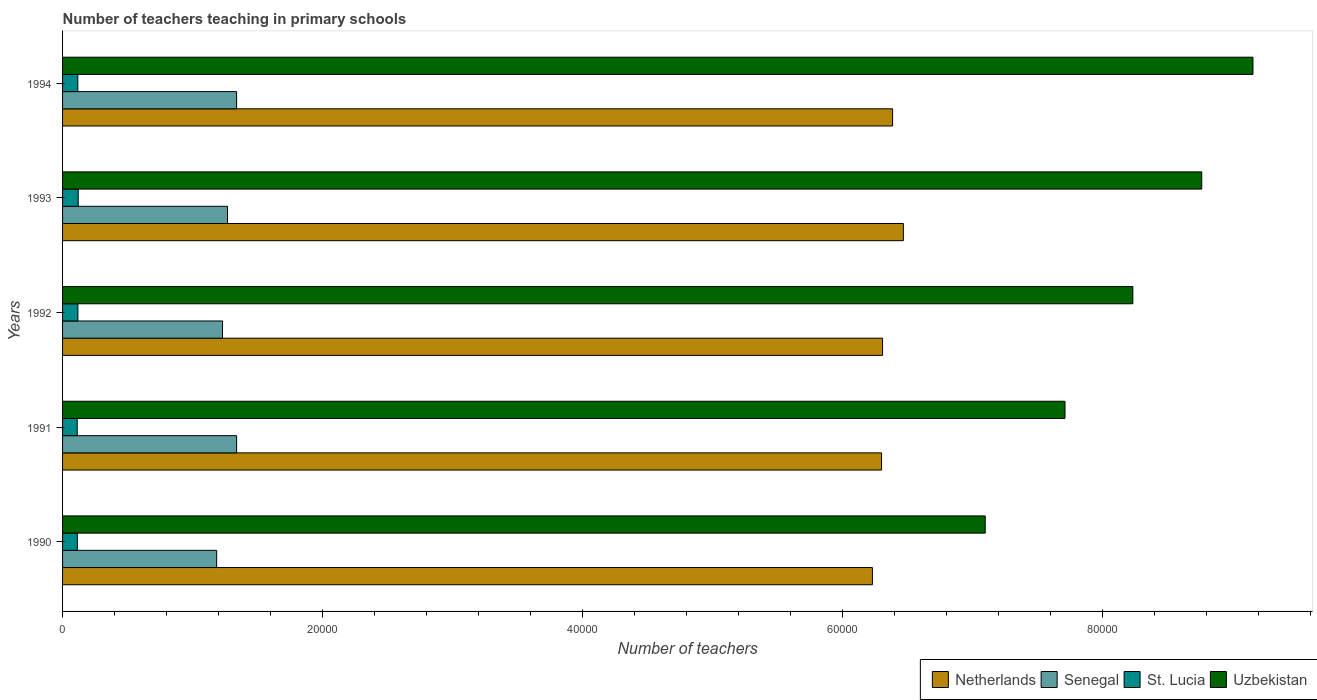How many groups of bars are there?
Your answer should be compact. 5. Are the number of bars per tick equal to the number of legend labels?
Offer a very short reply. Yes. Are the number of bars on each tick of the Y-axis equal?
Your answer should be very brief. Yes. How many bars are there on the 3rd tick from the top?
Provide a succinct answer. 4. What is the number of teachers teaching in primary schools in Senegal in 1990?
Keep it short and to the point. 1.19e+04. Across all years, what is the maximum number of teachers teaching in primary schools in Netherlands?
Provide a short and direct response. 6.47e+04. Across all years, what is the minimum number of teachers teaching in primary schools in St. Lucia?
Offer a very short reply. 1127. In which year was the number of teachers teaching in primary schools in St. Lucia maximum?
Ensure brevity in your answer.  1993. What is the total number of teachers teaching in primary schools in Uzbekistan in the graph?
Offer a terse response. 4.10e+05. What is the difference between the number of teachers teaching in primary schools in Uzbekistan in 1990 and that in 1991?
Offer a very short reply. -6139. What is the difference between the number of teachers teaching in primary schools in Senegal in 1990 and the number of teachers teaching in primary schools in Netherlands in 1991?
Offer a terse response. -5.12e+04. What is the average number of teachers teaching in primary schools in Senegal per year?
Give a very brief answer. 1.27e+04. In the year 1993, what is the difference between the number of teachers teaching in primary schools in Uzbekistan and number of teachers teaching in primary schools in Senegal?
Make the answer very short. 7.50e+04. What is the ratio of the number of teachers teaching in primary schools in Netherlands in 1990 to that in 1991?
Give a very brief answer. 0.99. Is the number of teachers teaching in primary schools in Senegal in 1990 less than that in 1992?
Give a very brief answer. Yes. Is the difference between the number of teachers teaching in primary schools in Uzbekistan in 1991 and 1993 greater than the difference between the number of teachers teaching in primary schools in Senegal in 1991 and 1993?
Keep it short and to the point. No. What is the difference between the highest and the lowest number of teachers teaching in primary schools in Senegal?
Provide a short and direct response. 1535. What does the 3rd bar from the bottom in 1991 represents?
Your answer should be compact. St. Lucia. Is it the case that in every year, the sum of the number of teachers teaching in primary schools in Senegal and number of teachers teaching in primary schools in St. Lucia is greater than the number of teachers teaching in primary schools in Uzbekistan?
Keep it short and to the point. No. Are all the bars in the graph horizontal?
Provide a short and direct response. Yes. What is the difference between two consecutive major ticks on the X-axis?
Your response must be concise. 2.00e+04. Are the values on the major ticks of X-axis written in scientific E-notation?
Keep it short and to the point. No. Where does the legend appear in the graph?
Your response must be concise. Bottom right. How many legend labels are there?
Offer a very short reply. 4. How are the legend labels stacked?
Your answer should be very brief. Horizontal. What is the title of the graph?
Provide a succinct answer. Number of teachers teaching in primary schools. What is the label or title of the X-axis?
Keep it short and to the point. Number of teachers. What is the label or title of the Y-axis?
Your response must be concise. Years. What is the Number of teachers in Netherlands in 1990?
Ensure brevity in your answer.  6.23e+04. What is the Number of teachers of Senegal in 1990?
Your response must be concise. 1.19e+04. What is the Number of teachers of St. Lucia in 1990?
Your answer should be very brief. 1137. What is the Number of teachers in Uzbekistan in 1990?
Provide a short and direct response. 7.10e+04. What is the Number of teachers of Netherlands in 1991?
Provide a short and direct response. 6.30e+04. What is the Number of teachers of Senegal in 1991?
Your answer should be very brief. 1.34e+04. What is the Number of teachers in St. Lucia in 1991?
Your answer should be compact. 1127. What is the Number of teachers in Uzbekistan in 1991?
Your response must be concise. 7.71e+04. What is the Number of teachers of Netherlands in 1992?
Your response must be concise. 6.31e+04. What is the Number of teachers in Senegal in 1992?
Offer a very short reply. 1.23e+04. What is the Number of teachers of St. Lucia in 1992?
Your answer should be very brief. 1181. What is the Number of teachers of Uzbekistan in 1992?
Give a very brief answer. 8.24e+04. What is the Number of teachers of Netherlands in 1993?
Keep it short and to the point. 6.47e+04. What is the Number of teachers of Senegal in 1993?
Provide a short and direct response. 1.27e+04. What is the Number of teachers of St. Lucia in 1993?
Give a very brief answer. 1204. What is the Number of teachers of Uzbekistan in 1993?
Make the answer very short. 8.77e+04. What is the Number of teachers of Netherlands in 1994?
Offer a terse response. 6.39e+04. What is the Number of teachers in Senegal in 1994?
Keep it short and to the point. 1.34e+04. What is the Number of teachers in St. Lucia in 1994?
Offer a terse response. 1174. What is the Number of teachers in Uzbekistan in 1994?
Ensure brevity in your answer.  9.16e+04. Across all years, what is the maximum Number of teachers in Netherlands?
Ensure brevity in your answer.  6.47e+04. Across all years, what is the maximum Number of teachers of Senegal?
Provide a succinct answer. 1.34e+04. Across all years, what is the maximum Number of teachers of St. Lucia?
Provide a succinct answer. 1204. Across all years, what is the maximum Number of teachers of Uzbekistan?
Keep it short and to the point. 9.16e+04. Across all years, what is the minimum Number of teachers in Netherlands?
Keep it short and to the point. 6.23e+04. Across all years, what is the minimum Number of teachers of Senegal?
Offer a terse response. 1.19e+04. Across all years, what is the minimum Number of teachers in St. Lucia?
Your answer should be compact. 1127. Across all years, what is the minimum Number of teachers of Uzbekistan?
Offer a very short reply. 7.10e+04. What is the total Number of teachers of Netherlands in the graph?
Give a very brief answer. 3.17e+05. What is the total Number of teachers in Senegal in the graph?
Your response must be concise. 6.36e+04. What is the total Number of teachers of St. Lucia in the graph?
Offer a very short reply. 5823. What is the total Number of teachers in Uzbekistan in the graph?
Offer a very short reply. 4.10e+05. What is the difference between the Number of teachers in Netherlands in 1990 and that in 1991?
Ensure brevity in your answer.  -703. What is the difference between the Number of teachers of Senegal in 1990 and that in 1991?
Your answer should be compact. -1535. What is the difference between the Number of teachers of Uzbekistan in 1990 and that in 1991?
Ensure brevity in your answer.  -6139. What is the difference between the Number of teachers in Netherlands in 1990 and that in 1992?
Provide a succinct answer. -781. What is the difference between the Number of teachers of Senegal in 1990 and that in 1992?
Provide a succinct answer. -448. What is the difference between the Number of teachers of St. Lucia in 1990 and that in 1992?
Ensure brevity in your answer.  -44. What is the difference between the Number of teachers in Uzbekistan in 1990 and that in 1992?
Give a very brief answer. -1.14e+04. What is the difference between the Number of teachers in Netherlands in 1990 and that in 1993?
Provide a succinct answer. -2381. What is the difference between the Number of teachers in Senegal in 1990 and that in 1993?
Ensure brevity in your answer.  -834. What is the difference between the Number of teachers in St. Lucia in 1990 and that in 1993?
Ensure brevity in your answer.  -67. What is the difference between the Number of teachers in Uzbekistan in 1990 and that in 1993?
Give a very brief answer. -1.67e+04. What is the difference between the Number of teachers of Netherlands in 1990 and that in 1994?
Ensure brevity in your answer.  -1553. What is the difference between the Number of teachers of Senegal in 1990 and that in 1994?
Your response must be concise. -1535. What is the difference between the Number of teachers of St. Lucia in 1990 and that in 1994?
Your response must be concise. -37. What is the difference between the Number of teachers of Uzbekistan in 1990 and that in 1994?
Your response must be concise. -2.06e+04. What is the difference between the Number of teachers in Netherlands in 1991 and that in 1992?
Give a very brief answer. -78. What is the difference between the Number of teachers in Senegal in 1991 and that in 1992?
Keep it short and to the point. 1087. What is the difference between the Number of teachers in St. Lucia in 1991 and that in 1992?
Give a very brief answer. -54. What is the difference between the Number of teachers of Uzbekistan in 1991 and that in 1992?
Provide a succinct answer. -5221. What is the difference between the Number of teachers of Netherlands in 1991 and that in 1993?
Your response must be concise. -1678. What is the difference between the Number of teachers in Senegal in 1991 and that in 1993?
Your answer should be very brief. 701. What is the difference between the Number of teachers in St. Lucia in 1991 and that in 1993?
Ensure brevity in your answer.  -77. What is the difference between the Number of teachers of Uzbekistan in 1991 and that in 1993?
Keep it short and to the point. -1.05e+04. What is the difference between the Number of teachers of Netherlands in 1991 and that in 1994?
Keep it short and to the point. -850. What is the difference between the Number of teachers in St. Lucia in 1991 and that in 1994?
Your response must be concise. -47. What is the difference between the Number of teachers in Uzbekistan in 1991 and that in 1994?
Your response must be concise. -1.45e+04. What is the difference between the Number of teachers in Netherlands in 1992 and that in 1993?
Make the answer very short. -1600. What is the difference between the Number of teachers in Senegal in 1992 and that in 1993?
Give a very brief answer. -386. What is the difference between the Number of teachers of Uzbekistan in 1992 and that in 1993?
Offer a terse response. -5301. What is the difference between the Number of teachers of Netherlands in 1992 and that in 1994?
Provide a short and direct response. -772. What is the difference between the Number of teachers of Senegal in 1992 and that in 1994?
Offer a terse response. -1087. What is the difference between the Number of teachers in St. Lucia in 1992 and that in 1994?
Your response must be concise. 7. What is the difference between the Number of teachers in Uzbekistan in 1992 and that in 1994?
Offer a terse response. -9244. What is the difference between the Number of teachers of Netherlands in 1993 and that in 1994?
Your answer should be very brief. 828. What is the difference between the Number of teachers in Senegal in 1993 and that in 1994?
Offer a very short reply. -701. What is the difference between the Number of teachers in St. Lucia in 1993 and that in 1994?
Offer a very short reply. 30. What is the difference between the Number of teachers in Uzbekistan in 1993 and that in 1994?
Provide a succinct answer. -3943. What is the difference between the Number of teachers of Netherlands in 1990 and the Number of teachers of Senegal in 1991?
Provide a succinct answer. 4.89e+04. What is the difference between the Number of teachers in Netherlands in 1990 and the Number of teachers in St. Lucia in 1991?
Your answer should be compact. 6.12e+04. What is the difference between the Number of teachers of Netherlands in 1990 and the Number of teachers of Uzbekistan in 1991?
Make the answer very short. -1.48e+04. What is the difference between the Number of teachers in Senegal in 1990 and the Number of teachers in St. Lucia in 1991?
Your response must be concise. 1.07e+04. What is the difference between the Number of teachers of Senegal in 1990 and the Number of teachers of Uzbekistan in 1991?
Your answer should be very brief. -6.53e+04. What is the difference between the Number of teachers of St. Lucia in 1990 and the Number of teachers of Uzbekistan in 1991?
Your answer should be compact. -7.60e+04. What is the difference between the Number of teachers of Netherlands in 1990 and the Number of teachers of Senegal in 1992?
Make the answer very short. 5.00e+04. What is the difference between the Number of teachers of Netherlands in 1990 and the Number of teachers of St. Lucia in 1992?
Provide a succinct answer. 6.11e+04. What is the difference between the Number of teachers of Netherlands in 1990 and the Number of teachers of Uzbekistan in 1992?
Provide a succinct answer. -2.00e+04. What is the difference between the Number of teachers of Senegal in 1990 and the Number of teachers of St. Lucia in 1992?
Give a very brief answer. 1.07e+04. What is the difference between the Number of teachers in Senegal in 1990 and the Number of teachers in Uzbekistan in 1992?
Offer a very short reply. -7.05e+04. What is the difference between the Number of teachers in St. Lucia in 1990 and the Number of teachers in Uzbekistan in 1992?
Keep it short and to the point. -8.12e+04. What is the difference between the Number of teachers of Netherlands in 1990 and the Number of teachers of Senegal in 1993?
Provide a short and direct response. 4.96e+04. What is the difference between the Number of teachers of Netherlands in 1990 and the Number of teachers of St. Lucia in 1993?
Your answer should be compact. 6.11e+04. What is the difference between the Number of teachers in Netherlands in 1990 and the Number of teachers in Uzbekistan in 1993?
Give a very brief answer. -2.53e+04. What is the difference between the Number of teachers in Senegal in 1990 and the Number of teachers in St. Lucia in 1993?
Your answer should be compact. 1.07e+04. What is the difference between the Number of teachers in Senegal in 1990 and the Number of teachers in Uzbekistan in 1993?
Your response must be concise. -7.58e+04. What is the difference between the Number of teachers of St. Lucia in 1990 and the Number of teachers of Uzbekistan in 1993?
Your answer should be compact. -8.65e+04. What is the difference between the Number of teachers in Netherlands in 1990 and the Number of teachers in Senegal in 1994?
Ensure brevity in your answer.  4.89e+04. What is the difference between the Number of teachers in Netherlands in 1990 and the Number of teachers in St. Lucia in 1994?
Offer a very short reply. 6.11e+04. What is the difference between the Number of teachers in Netherlands in 1990 and the Number of teachers in Uzbekistan in 1994?
Provide a short and direct response. -2.93e+04. What is the difference between the Number of teachers of Senegal in 1990 and the Number of teachers of St. Lucia in 1994?
Keep it short and to the point. 1.07e+04. What is the difference between the Number of teachers of Senegal in 1990 and the Number of teachers of Uzbekistan in 1994?
Offer a terse response. -7.97e+04. What is the difference between the Number of teachers of St. Lucia in 1990 and the Number of teachers of Uzbekistan in 1994?
Provide a succinct answer. -9.05e+04. What is the difference between the Number of teachers in Netherlands in 1991 and the Number of teachers in Senegal in 1992?
Provide a short and direct response. 5.07e+04. What is the difference between the Number of teachers of Netherlands in 1991 and the Number of teachers of St. Lucia in 1992?
Your response must be concise. 6.18e+04. What is the difference between the Number of teachers in Netherlands in 1991 and the Number of teachers in Uzbekistan in 1992?
Your answer should be compact. -1.93e+04. What is the difference between the Number of teachers of Senegal in 1991 and the Number of teachers of St. Lucia in 1992?
Provide a succinct answer. 1.22e+04. What is the difference between the Number of teachers in Senegal in 1991 and the Number of teachers in Uzbekistan in 1992?
Ensure brevity in your answer.  -6.90e+04. What is the difference between the Number of teachers in St. Lucia in 1991 and the Number of teachers in Uzbekistan in 1992?
Make the answer very short. -8.12e+04. What is the difference between the Number of teachers of Netherlands in 1991 and the Number of teachers of Senegal in 1993?
Offer a terse response. 5.03e+04. What is the difference between the Number of teachers in Netherlands in 1991 and the Number of teachers in St. Lucia in 1993?
Your answer should be compact. 6.18e+04. What is the difference between the Number of teachers in Netherlands in 1991 and the Number of teachers in Uzbekistan in 1993?
Provide a succinct answer. -2.46e+04. What is the difference between the Number of teachers in Senegal in 1991 and the Number of teachers in St. Lucia in 1993?
Offer a very short reply. 1.22e+04. What is the difference between the Number of teachers in Senegal in 1991 and the Number of teachers in Uzbekistan in 1993?
Your answer should be compact. -7.43e+04. What is the difference between the Number of teachers in St. Lucia in 1991 and the Number of teachers in Uzbekistan in 1993?
Provide a short and direct response. -8.65e+04. What is the difference between the Number of teachers of Netherlands in 1991 and the Number of teachers of Senegal in 1994?
Offer a terse response. 4.96e+04. What is the difference between the Number of teachers of Netherlands in 1991 and the Number of teachers of St. Lucia in 1994?
Give a very brief answer. 6.18e+04. What is the difference between the Number of teachers in Netherlands in 1991 and the Number of teachers in Uzbekistan in 1994?
Provide a short and direct response. -2.86e+04. What is the difference between the Number of teachers of Senegal in 1991 and the Number of teachers of St. Lucia in 1994?
Make the answer very short. 1.22e+04. What is the difference between the Number of teachers of Senegal in 1991 and the Number of teachers of Uzbekistan in 1994?
Make the answer very short. -7.82e+04. What is the difference between the Number of teachers of St. Lucia in 1991 and the Number of teachers of Uzbekistan in 1994?
Your response must be concise. -9.05e+04. What is the difference between the Number of teachers of Netherlands in 1992 and the Number of teachers of Senegal in 1993?
Your response must be concise. 5.04e+04. What is the difference between the Number of teachers in Netherlands in 1992 and the Number of teachers in St. Lucia in 1993?
Ensure brevity in your answer.  6.19e+04. What is the difference between the Number of teachers in Netherlands in 1992 and the Number of teachers in Uzbekistan in 1993?
Provide a succinct answer. -2.46e+04. What is the difference between the Number of teachers in Senegal in 1992 and the Number of teachers in St. Lucia in 1993?
Give a very brief answer. 1.11e+04. What is the difference between the Number of teachers in Senegal in 1992 and the Number of teachers in Uzbekistan in 1993?
Offer a very short reply. -7.54e+04. What is the difference between the Number of teachers of St. Lucia in 1992 and the Number of teachers of Uzbekistan in 1993?
Make the answer very short. -8.65e+04. What is the difference between the Number of teachers in Netherlands in 1992 and the Number of teachers in Senegal in 1994?
Keep it short and to the point. 4.97e+04. What is the difference between the Number of teachers of Netherlands in 1992 and the Number of teachers of St. Lucia in 1994?
Offer a terse response. 6.19e+04. What is the difference between the Number of teachers of Netherlands in 1992 and the Number of teachers of Uzbekistan in 1994?
Give a very brief answer. -2.85e+04. What is the difference between the Number of teachers in Senegal in 1992 and the Number of teachers in St. Lucia in 1994?
Offer a terse response. 1.11e+04. What is the difference between the Number of teachers of Senegal in 1992 and the Number of teachers of Uzbekistan in 1994?
Your answer should be compact. -7.93e+04. What is the difference between the Number of teachers in St. Lucia in 1992 and the Number of teachers in Uzbekistan in 1994?
Keep it short and to the point. -9.04e+04. What is the difference between the Number of teachers of Netherlands in 1993 and the Number of teachers of Senegal in 1994?
Ensure brevity in your answer.  5.13e+04. What is the difference between the Number of teachers in Netherlands in 1993 and the Number of teachers in St. Lucia in 1994?
Keep it short and to the point. 6.35e+04. What is the difference between the Number of teachers of Netherlands in 1993 and the Number of teachers of Uzbekistan in 1994?
Give a very brief answer. -2.69e+04. What is the difference between the Number of teachers in Senegal in 1993 and the Number of teachers in St. Lucia in 1994?
Make the answer very short. 1.15e+04. What is the difference between the Number of teachers in Senegal in 1993 and the Number of teachers in Uzbekistan in 1994?
Offer a very short reply. -7.89e+04. What is the difference between the Number of teachers in St. Lucia in 1993 and the Number of teachers in Uzbekistan in 1994?
Your response must be concise. -9.04e+04. What is the average Number of teachers of Netherlands per year?
Provide a succinct answer. 6.34e+04. What is the average Number of teachers of Senegal per year?
Offer a very short reply. 1.27e+04. What is the average Number of teachers of St. Lucia per year?
Offer a terse response. 1164.6. What is the average Number of teachers in Uzbekistan per year?
Provide a short and direct response. 8.20e+04. In the year 1990, what is the difference between the Number of teachers in Netherlands and Number of teachers in Senegal?
Provide a succinct answer. 5.05e+04. In the year 1990, what is the difference between the Number of teachers of Netherlands and Number of teachers of St. Lucia?
Give a very brief answer. 6.12e+04. In the year 1990, what is the difference between the Number of teachers in Netherlands and Number of teachers in Uzbekistan?
Provide a succinct answer. -8681. In the year 1990, what is the difference between the Number of teachers of Senegal and Number of teachers of St. Lucia?
Offer a terse response. 1.07e+04. In the year 1990, what is the difference between the Number of teachers of Senegal and Number of teachers of Uzbekistan?
Offer a very short reply. -5.91e+04. In the year 1990, what is the difference between the Number of teachers in St. Lucia and Number of teachers in Uzbekistan?
Your response must be concise. -6.99e+04. In the year 1991, what is the difference between the Number of teachers of Netherlands and Number of teachers of Senegal?
Provide a succinct answer. 4.96e+04. In the year 1991, what is the difference between the Number of teachers of Netherlands and Number of teachers of St. Lucia?
Your response must be concise. 6.19e+04. In the year 1991, what is the difference between the Number of teachers of Netherlands and Number of teachers of Uzbekistan?
Provide a succinct answer. -1.41e+04. In the year 1991, what is the difference between the Number of teachers in Senegal and Number of teachers in St. Lucia?
Offer a terse response. 1.23e+04. In the year 1991, what is the difference between the Number of teachers of Senegal and Number of teachers of Uzbekistan?
Keep it short and to the point. -6.37e+04. In the year 1991, what is the difference between the Number of teachers of St. Lucia and Number of teachers of Uzbekistan?
Offer a very short reply. -7.60e+04. In the year 1992, what is the difference between the Number of teachers in Netherlands and Number of teachers in Senegal?
Your answer should be very brief. 5.08e+04. In the year 1992, what is the difference between the Number of teachers of Netherlands and Number of teachers of St. Lucia?
Give a very brief answer. 6.19e+04. In the year 1992, what is the difference between the Number of teachers in Netherlands and Number of teachers in Uzbekistan?
Your response must be concise. -1.93e+04. In the year 1992, what is the difference between the Number of teachers in Senegal and Number of teachers in St. Lucia?
Your response must be concise. 1.11e+04. In the year 1992, what is the difference between the Number of teachers in Senegal and Number of teachers in Uzbekistan?
Your answer should be very brief. -7.01e+04. In the year 1992, what is the difference between the Number of teachers in St. Lucia and Number of teachers in Uzbekistan?
Provide a succinct answer. -8.12e+04. In the year 1993, what is the difference between the Number of teachers in Netherlands and Number of teachers in Senegal?
Your answer should be very brief. 5.20e+04. In the year 1993, what is the difference between the Number of teachers of Netherlands and Number of teachers of St. Lucia?
Your response must be concise. 6.35e+04. In the year 1993, what is the difference between the Number of teachers of Netherlands and Number of teachers of Uzbekistan?
Offer a very short reply. -2.30e+04. In the year 1993, what is the difference between the Number of teachers of Senegal and Number of teachers of St. Lucia?
Make the answer very short. 1.15e+04. In the year 1993, what is the difference between the Number of teachers of Senegal and Number of teachers of Uzbekistan?
Ensure brevity in your answer.  -7.50e+04. In the year 1993, what is the difference between the Number of teachers in St. Lucia and Number of teachers in Uzbekistan?
Your response must be concise. -8.65e+04. In the year 1994, what is the difference between the Number of teachers of Netherlands and Number of teachers of Senegal?
Your response must be concise. 5.05e+04. In the year 1994, what is the difference between the Number of teachers of Netherlands and Number of teachers of St. Lucia?
Give a very brief answer. 6.27e+04. In the year 1994, what is the difference between the Number of teachers in Netherlands and Number of teachers in Uzbekistan?
Give a very brief answer. -2.77e+04. In the year 1994, what is the difference between the Number of teachers of Senegal and Number of teachers of St. Lucia?
Keep it short and to the point. 1.22e+04. In the year 1994, what is the difference between the Number of teachers in Senegal and Number of teachers in Uzbekistan?
Make the answer very short. -7.82e+04. In the year 1994, what is the difference between the Number of teachers in St. Lucia and Number of teachers in Uzbekistan?
Your response must be concise. -9.04e+04. What is the ratio of the Number of teachers of Netherlands in 1990 to that in 1991?
Your answer should be very brief. 0.99. What is the ratio of the Number of teachers in Senegal in 1990 to that in 1991?
Ensure brevity in your answer.  0.89. What is the ratio of the Number of teachers in St. Lucia in 1990 to that in 1991?
Provide a short and direct response. 1.01. What is the ratio of the Number of teachers of Uzbekistan in 1990 to that in 1991?
Offer a terse response. 0.92. What is the ratio of the Number of teachers of Netherlands in 1990 to that in 1992?
Provide a short and direct response. 0.99. What is the ratio of the Number of teachers of Senegal in 1990 to that in 1992?
Your response must be concise. 0.96. What is the ratio of the Number of teachers in St. Lucia in 1990 to that in 1992?
Offer a terse response. 0.96. What is the ratio of the Number of teachers of Uzbekistan in 1990 to that in 1992?
Your answer should be very brief. 0.86. What is the ratio of the Number of teachers of Netherlands in 1990 to that in 1993?
Ensure brevity in your answer.  0.96. What is the ratio of the Number of teachers in Senegal in 1990 to that in 1993?
Give a very brief answer. 0.93. What is the ratio of the Number of teachers of St. Lucia in 1990 to that in 1993?
Provide a succinct answer. 0.94. What is the ratio of the Number of teachers of Uzbekistan in 1990 to that in 1993?
Make the answer very short. 0.81. What is the ratio of the Number of teachers in Netherlands in 1990 to that in 1994?
Offer a very short reply. 0.98. What is the ratio of the Number of teachers in Senegal in 1990 to that in 1994?
Make the answer very short. 0.89. What is the ratio of the Number of teachers of St. Lucia in 1990 to that in 1994?
Your answer should be very brief. 0.97. What is the ratio of the Number of teachers of Uzbekistan in 1990 to that in 1994?
Your answer should be compact. 0.78. What is the ratio of the Number of teachers of Senegal in 1991 to that in 1992?
Offer a terse response. 1.09. What is the ratio of the Number of teachers of St. Lucia in 1991 to that in 1992?
Your response must be concise. 0.95. What is the ratio of the Number of teachers in Uzbekistan in 1991 to that in 1992?
Keep it short and to the point. 0.94. What is the ratio of the Number of teachers of Netherlands in 1991 to that in 1993?
Offer a terse response. 0.97. What is the ratio of the Number of teachers in Senegal in 1991 to that in 1993?
Give a very brief answer. 1.06. What is the ratio of the Number of teachers in St. Lucia in 1991 to that in 1993?
Your answer should be very brief. 0.94. What is the ratio of the Number of teachers in Uzbekistan in 1991 to that in 1993?
Provide a short and direct response. 0.88. What is the ratio of the Number of teachers of Netherlands in 1991 to that in 1994?
Your answer should be compact. 0.99. What is the ratio of the Number of teachers in St. Lucia in 1991 to that in 1994?
Give a very brief answer. 0.96. What is the ratio of the Number of teachers in Uzbekistan in 1991 to that in 1994?
Provide a short and direct response. 0.84. What is the ratio of the Number of teachers of Netherlands in 1992 to that in 1993?
Your answer should be very brief. 0.98. What is the ratio of the Number of teachers of Senegal in 1992 to that in 1993?
Provide a succinct answer. 0.97. What is the ratio of the Number of teachers of St. Lucia in 1992 to that in 1993?
Keep it short and to the point. 0.98. What is the ratio of the Number of teachers in Uzbekistan in 1992 to that in 1993?
Give a very brief answer. 0.94. What is the ratio of the Number of teachers in Netherlands in 1992 to that in 1994?
Your answer should be very brief. 0.99. What is the ratio of the Number of teachers of Senegal in 1992 to that in 1994?
Keep it short and to the point. 0.92. What is the ratio of the Number of teachers in Uzbekistan in 1992 to that in 1994?
Your response must be concise. 0.9. What is the ratio of the Number of teachers of Netherlands in 1993 to that in 1994?
Keep it short and to the point. 1.01. What is the ratio of the Number of teachers of Senegal in 1993 to that in 1994?
Provide a succinct answer. 0.95. What is the ratio of the Number of teachers in St. Lucia in 1993 to that in 1994?
Keep it short and to the point. 1.03. What is the ratio of the Number of teachers of Uzbekistan in 1993 to that in 1994?
Your answer should be compact. 0.96. What is the difference between the highest and the second highest Number of teachers in Netherlands?
Make the answer very short. 828. What is the difference between the highest and the second highest Number of teachers in Senegal?
Keep it short and to the point. 0. What is the difference between the highest and the second highest Number of teachers in Uzbekistan?
Give a very brief answer. 3943. What is the difference between the highest and the lowest Number of teachers of Netherlands?
Make the answer very short. 2381. What is the difference between the highest and the lowest Number of teachers in Senegal?
Provide a short and direct response. 1535. What is the difference between the highest and the lowest Number of teachers in Uzbekistan?
Offer a terse response. 2.06e+04. 